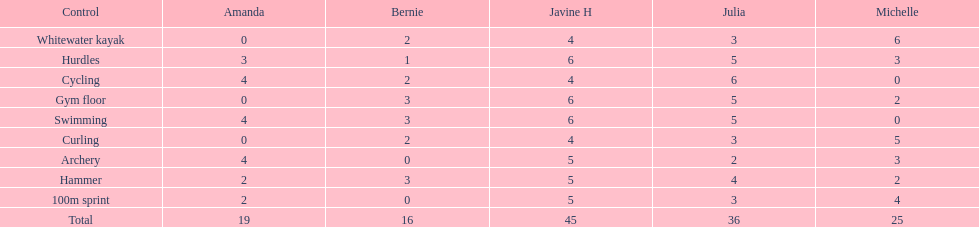Who runs the quickest among the runners? Javine H. 